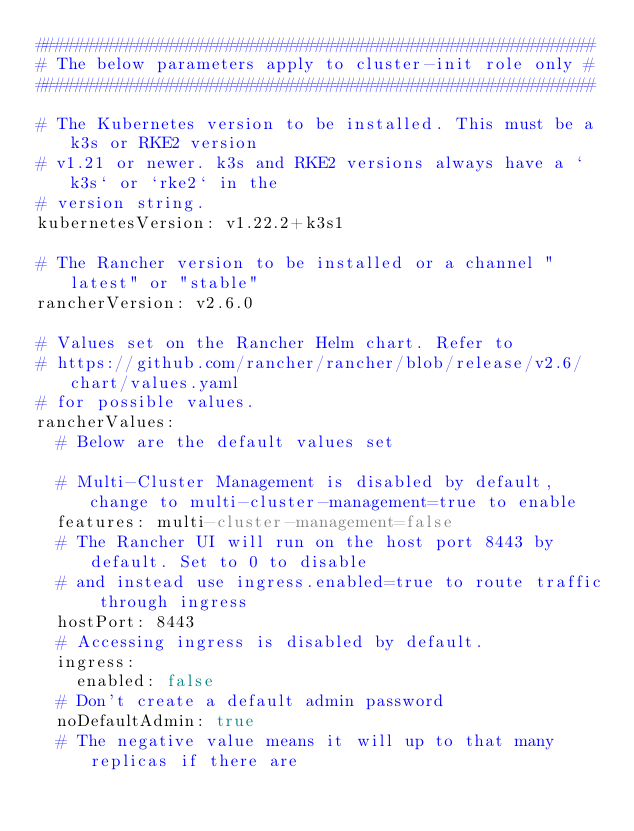<code> <loc_0><loc_0><loc_500><loc_500><_YAML_>########################################################
# The below parameters apply to cluster-init role only #
########################################################

# The Kubernetes version to be installed. This must be a k3s or RKE2 version
# v1.21 or newer. k3s and RKE2 versions always have a `k3s` or `rke2` in the
# version string.
kubernetesVersion: v1.22.2+k3s1

# The Rancher version to be installed or a channel "latest" or "stable"
rancherVersion: v2.6.0

# Values set on the Rancher Helm chart. Refer to
# https://github.com/rancher/rancher/blob/release/v2.6/chart/values.yaml
# for possible values.
rancherValues:
  # Below are the default values set

  # Multi-Cluster Management is disabled by default, change to multi-cluster-management=true to enable
  features: multi-cluster-management=false
  # The Rancher UI will run on the host port 8443 by default. Set to 0 to disable
  # and instead use ingress.enabled=true to route traffic through ingress
  hostPort: 8443
  # Accessing ingress is disabled by default.
  ingress:
    enabled: false
  # Don't create a default admin password
  noDefaultAdmin: true
  # The negative value means it will up to that many replicas if there are</code> 